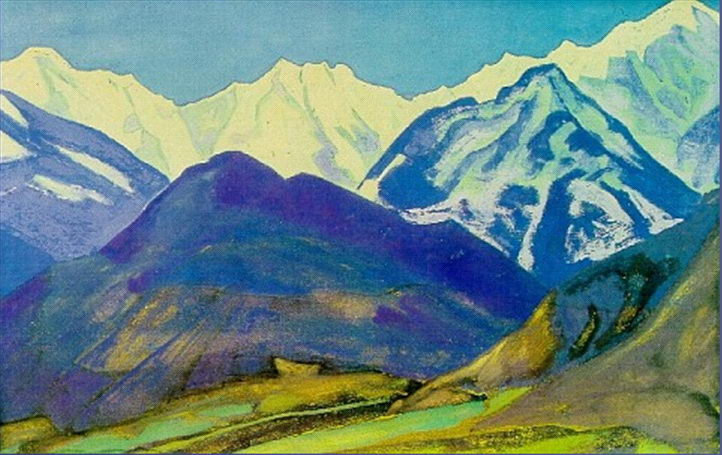Describe the possible historical context of these mountains. These mountains have stood for millennia, their majestic peaks witnessing the rise and fall of civilizations. In ancient times, they might have been regarded as sacred, hosting rituals and spiritual pilgrimages. Indigenous tribes could have revered them, embedding them in folklore and myths, ascribing them with spirits and gods. As empires expanded, these rigorous terrains could have served as natural fortresses, providing refuge and strategic advantage in times of conflict. The valleys may have fostered early agricultural communities, nurturing the first seeds of civilization in their fertile soil. Over centuries, travelers, artists, and poets have been drawn to these breathtaking vistas, their works and tales enriching the cultural tapestry and preserving the timeless allure of these majestic highlands.  How might a modern-day artist approach this landscape differently? A contemporary artist might approach this landscape with a variety of techniques, possibly experimenting with digital methods to capture its essence in new ways. Utilizing drones, they might take aerial shots, offering perspectives previously inaccessible. They could use mixed media, blending traditional paints with digital enhancements to create dynamic textures and lighting effects. Environmental awareness might also feature prominently, merging art with activism to highlight the significance of preserving such natural wonders. Alternatively, the artist could engage with the landscape in interactive art forms, creating immersive experiences for viewers using virtual reality, allowing people to explore the mountainscape intimately. This modern interpretation would blend reverence for natural beauty with innovative techniques, offering fresh, impactful ways to connect with this timeless scenery. 